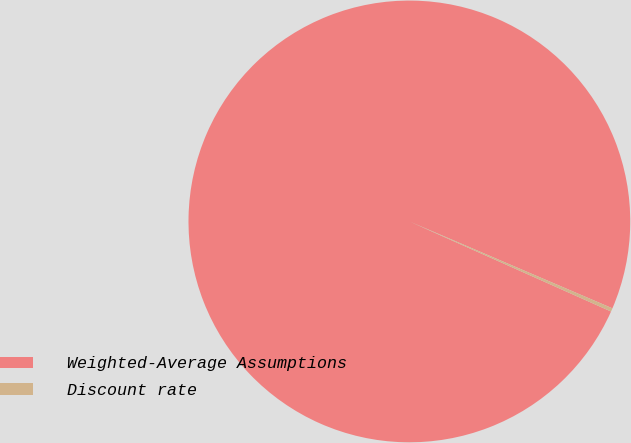<chart> <loc_0><loc_0><loc_500><loc_500><pie_chart><fcel>Weighted-Average Assumptions<fcel>Discount rate<nl><fcel>99.75%<fcel>0.25%<nl></chart> 